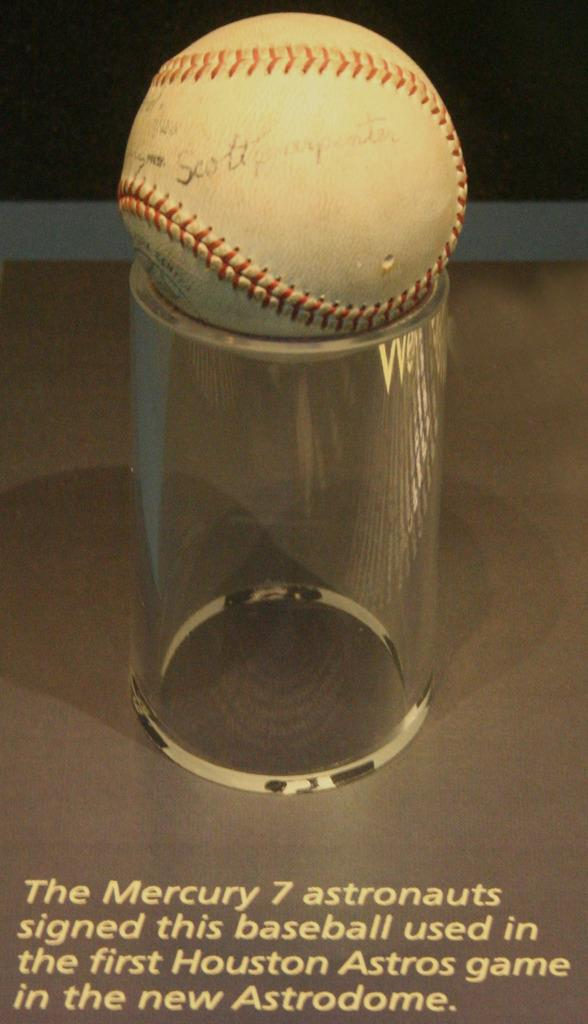What object is placed at the top of a glass in the image? There is a ball at the top of a glass in the image. What can be found at the bottom of the image? There is text at the bottom of the image. Where is the scarecrow located in the image? There is no scarecrow present in the image. What type of seed is growing in the knee of the person in the image? There is no person or seed present in the image. 